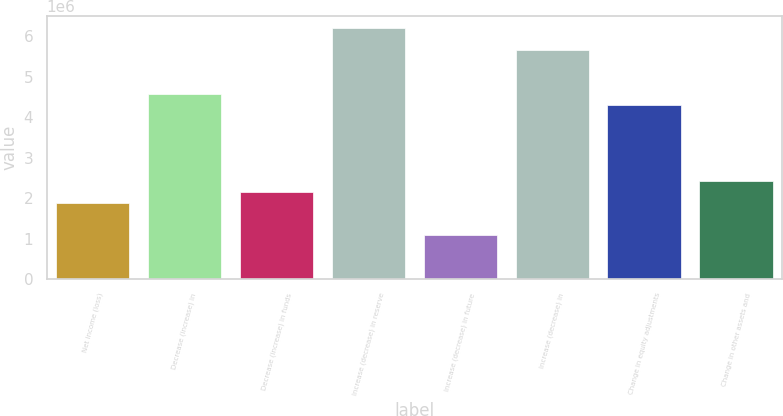Convert chart to OTSL. <chart><loc_0><loc_0><loc_500><loc_500><bar_chart><fcel>Net income (loss)<fcel>Decrease (increase) in<fcel>Decrease (increase) in funds<fcel>Increase (decrease) in reserve<fcel>Increase (decrease) in future<fcel>Increase (decrease) in<fcel>Change in equity adjustments<fcel>Change in other assets and<nl><fcel>1.88435e+06<fcel>4.57603e+06<fcel>2.15352e+06<fcel>6.19104e+06<fcel>1.07685e+06<fcel>5.6527e+06<fcel>4.30686e+06<fcel>2.42269e+06<nl></chart> 